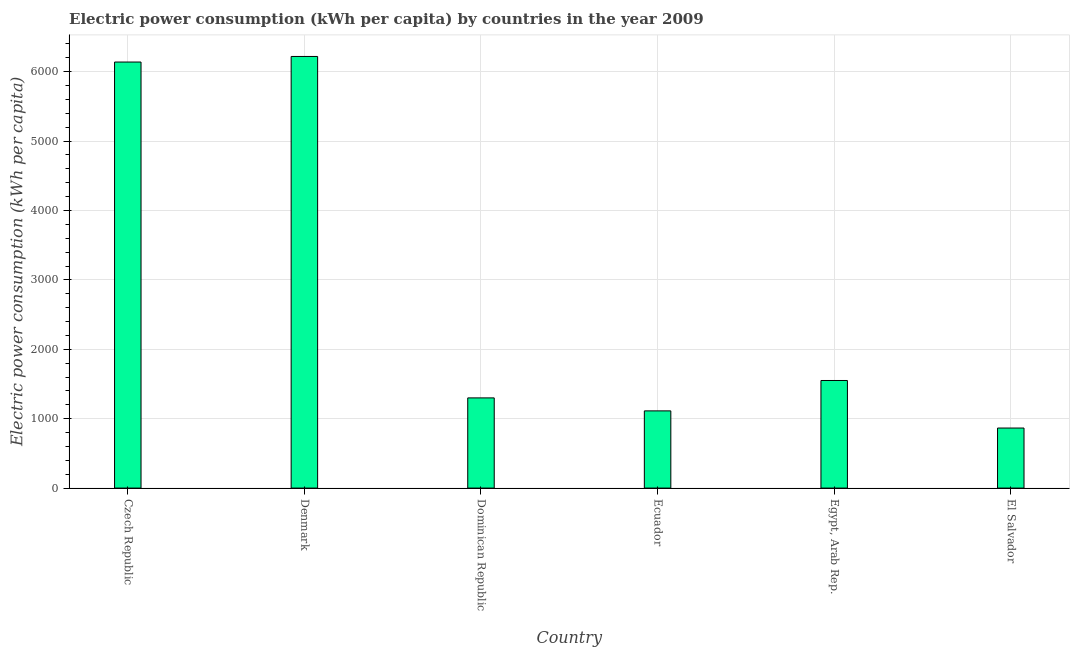What is the title of the graph?
Make the answer very short. Electric power consumption (kWh per capita) by countries in the year 2009. What is the label or title of the X-axis?
Provide a succinct answer. Country. What is the label or title of the Y-axis?
Offer a very short reply. Electric power consumption (kWh per capita). What is the electric power consumption in Czech Republic?
Offer a terse response. 6139.35. Across all countries, what is the maximum electric power consumption?
Your answer should be compact. 6219.7. Across all countries, what is the minimum electric power consumption?
Give a very brief answer. 865.25. In which country was the electric power consumption maximum?
Offer a very short reply. Denmark. In which country was the electric power consumption minimum?
Provide a succinct answer. El Salvador. What is the sum of the electric power consumption?
Your answer should be very brief. 1.72e+04. What is the difference between the electric power consumption in Denmark and Ecuador?
Your response must be concise. 5107.21. What is the average electric power consumption per country?
Provide a short and direct response. 2864.5. What is the median electric power consumption?
Make the answer very short. 1425.09. In how many countries, is the electric power consumption greater than 1600 kWh per capita?
Your answer should be compact. 2. What is the ratio of the electric power consumption in Ecuador to that in El Salvador?
Ensure brevity in your answer.  1.29. Is the electric power consumption in Czech Republic less than that in Egypt, Arab Rep.?
Your answer should be compact. No. Is the difference between the electric power consumption in Czech Republic and Egypt, Arab Rep. greater than the difference between any two countries?
Keep it short and to the point. No. What is the difference between the highest and the second highest electric power consumption?
Offer a terse response. 80.35. What is the difference between the highest and the lowest electric power consumption?
Make the answer very short. 5354.45. Are all the bars in the graph horizontal?
Your answer should be very brief. No. How many countries are there in the graph?
Give a very brief answer. 6. What is the difference between two consecutive major ticks on the Y-axis?
Provide a short and direct response. 1000. What is the Electric power consumption (kWh per capita) in Czech Republic?
Your answer should be very brief. 6139.35. What is the Electric power consumption (kWh per capita) of Denmark?
Offer a very short reply. 6219.7. What is the Electric power consumption (kWh per capita) of Dominican Republic?
Your response must be concise. 1299.69. What is the Electric power consumption (kWh per capita) in Ecuador?
Provide a succinct answer. 1112.49. What is the Electric power consumption (kWh per capita) in Egypt, Arab Rep.?
Ensure brevity in your answer.  1550.49. What is the Electric power consumption (kWh per capita) of El Salvador?
Your answer should be compact. 865.25. What is the difference between the Electric power consumption (kWh per capita) in Czech Republic and Denmark?
Your answer should be very brief. -80.35. What is the difference between the Electric power consumption (kWh per capita) in Czech Republic and Dominican Republic?
Provide a short and direct response. 4839.67. What is the difference between the Electric power consumption (kWh per capita) in Czech Republic and Ecuador?
Ensure brevity in your answer.  5026.86. What is the difference between the Electric power consumption (kWh per capita) in Czech Republic and Egypt, Arab Rep.?
Ensure brevity in your answer.  4588.86. What is the difference between the Electric power consumption (kWh per capita) in Czech Republic and El Salvador?
Provide a succinct answer. 5274.1. What is the difference between the Electric power consumption (kWh per capita) in Denmark and Dominican Republic?
Your answer should be very brief. 4920.01. What is the difference between the Electric power consumption (kWh per capita) in Denmark and Ecuador?
Provide a succinct answer. 5107.21. What is the difference between the Electric power consumption (kWh per capita) in Denmark and Egypt, Arab Rep.?
Provide a short and direct response. 4669.21. What is the difference between the Electric power consumption (kWh per capita) in Denmark and El Salvador?
Keep it short and to the point. 5354.45. What is the difference between the Electric power consumption (kWh per capita) in Dominican Republic and Ecuador?
Keep it short and to the point. 187.19. What is the difference between the Electric power consumption (kWh per capita) in Dominican Republic and Egypt, Arab Rep.?
Give a very brief answer. -250.8. What is the difference between the Electric power consumption (kWh per capita) in Dominican Republic and El Salvador?
Ensure brevity in your answer.  434.44. What is the difference between the Electric power consumption (kWh per capita) in Ecuador and Egypt, Arab Rep.?
Offer a terse response. -437.99. What is the difference between the Electric power consumption (kWh per capita) in Ecuador and El Salvador?
Provide a short and direct response. 247.24. What is the difference between the Electric power consumption (kWh per capita) in Egypt, Arab Rep. and El Salvador?
Provide a short and direct response. 685.24. What is the ratio of the Electric power consumption (kWh per capita) in Czech Republic to that in Denmark?
Give a very brief answer. 0.99. What is the ratio of the Electric power consumption (kWh per capita) in Czech Republic to that in Dominican Republic?
Ensure brevity in your answer.  4.72. What is the ratio of the Electric power consumption (kWh per capita) in Czech Republic to that in Ecuador?
Your answer should be compact. 5.52. What is the ratio of the Electric power consumption (kWh per capita) in Czech Republic to that in Egypt, Arab Rep.?
Your response must be concise. 3.96. What is the ratio of the Electric power consumption (kWh per capita) in Czech Republic to that in El Salvador?
Make the answer very short. 7.09. What is the ratio of the Electric power consumption (kWh per capita) in Denmark to that in Dominican Republic?
Give a very brief answer. 4.79. What is the ratio of the Electric power consumption (kWh per capita) in Denmark to that in Ecuador?
Make the answer very short. 5.59. What is the ratio of the Electric power consumption (kWh per capita) in Denmark to that in Egypt, Arab Rep.?
Ensure brevity in your answer.  4.01. What is the ratio of the Electric power consumption (kWh per capita) in Denmark to that in El Salvador?
Your answer should be compact. 7.19. What is the ratio of the Electric power consumption (kWh per capita) in Dominican Republic to that in Ecuador?
Your answer should be very brief. 1.17. What is the ratio of the Electric power consumption (kWh per capita) in Dominican Republic to that in Egypt, Arab Rep.?
Provide a succinct answer. 0.84. What is the ratio of the Electric power consumption (kWh per capita) in Dominican Republic to that in El Salvador?
Give a very brief answer. 1.5. What is the ratio of the Electric power consumption (kWh per capita) in Ecuador to that in Egypt, Arab Rep.?
Provide a short and direct response. 0.72. What is the ratio of the Electric power consumption (kWh per capita) in Ecuador to that in El Salvador?
Keep it short and to the point. 1.29. What is the ratio of the Electric power consumption (kWh per capita) in Egypt, Arab Rep. to that in El Salvador?
Give a very brief answer. 1.79. 